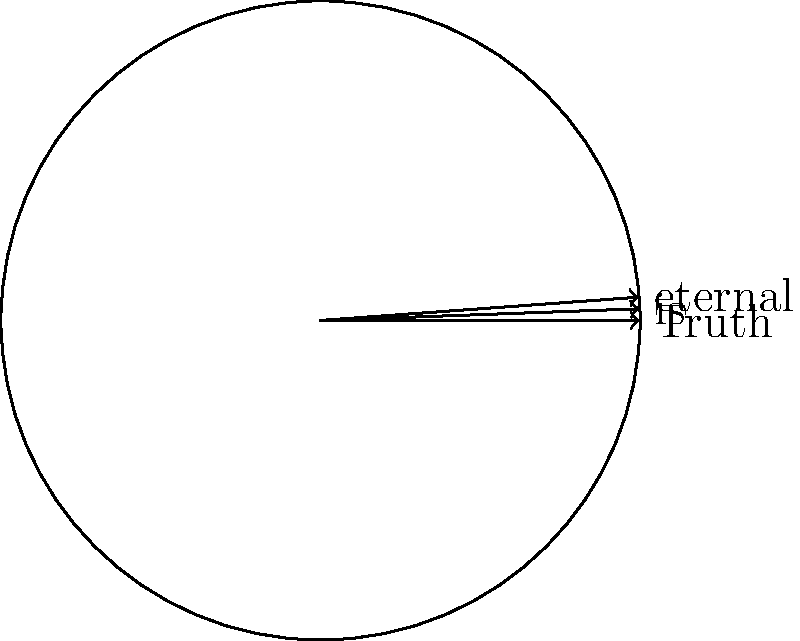In the image, a literary quote "Truth is eternal" is arranged around a circle. If the circle is rotated 120° clockwise, which word will appear at the top position where "Truth" currently resides? To solve this problem, we need to understand the principles of rotational symmetry and apply them to the given literary quote:

1. The quote "Truth is eternal" is divided into three words, each placed at equal intervals around the circle.

2. The angle between each word is 360° ÷ 3 = 120°.

3. A clockwise rotation of 120° is equivalent to moving each word one position in the opposite direction (counterclockwise).

4. Currently, the words are arranged counterclockwise in the order: "Truth", "is", "eternal".

5. After a 120° clockwise rotation:
   - "eternal" will move to the position of "Truth"
   - "Truth" will move to the position of "is"
   - "is" will move to the position of "eternal"

6. Therefore, after the rotation, "eternal" will appear at the top position where "Truth" currently resides.

This transformation reveals how the arrangement of words can alter our perception of the quote, potentially uncovering new interpretations or emphasizing different aspects of the statement.
Answer: eternal 